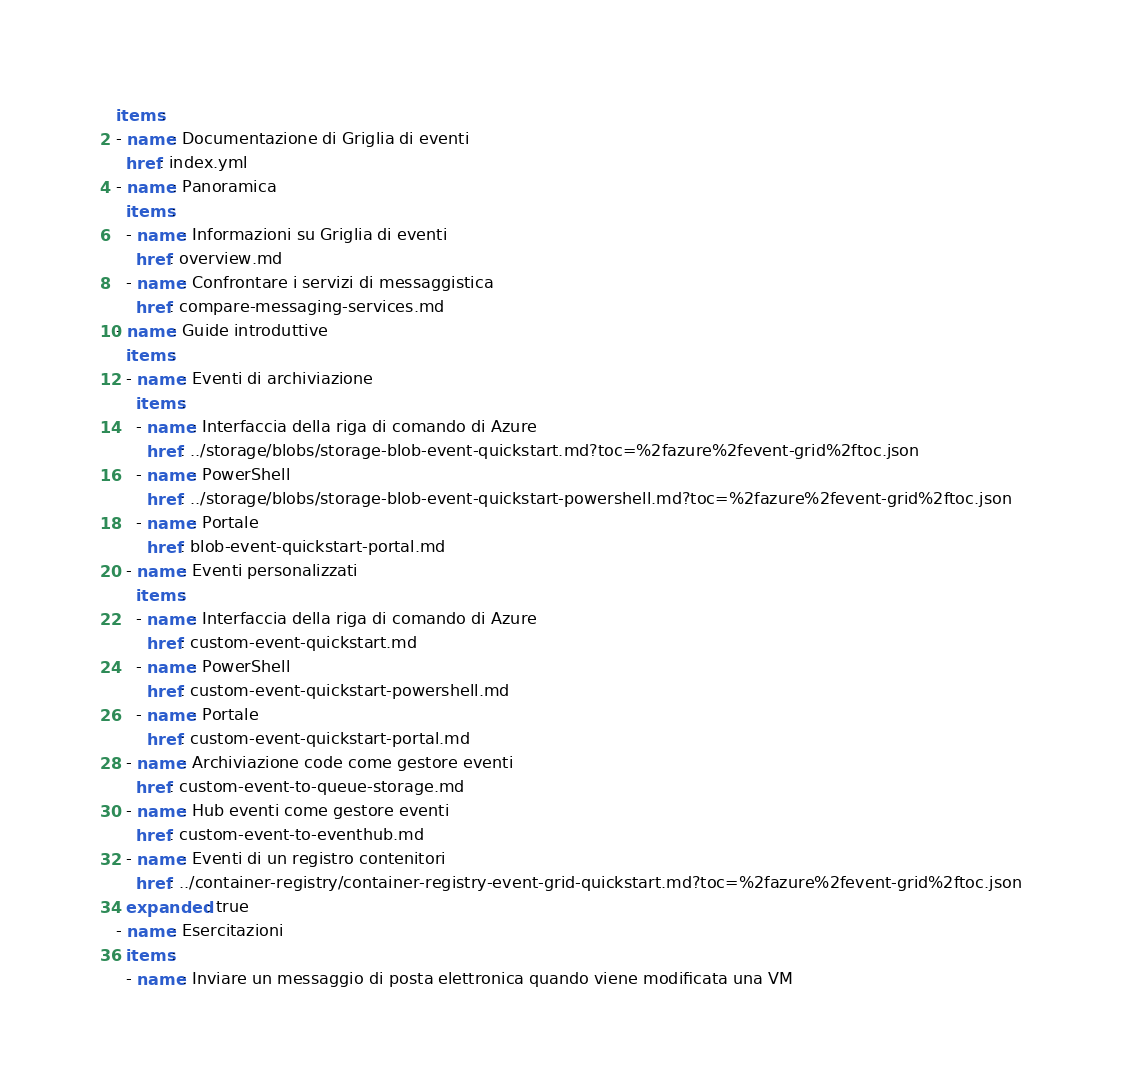<code> <loc_0><loc_0><loc_500><loc_500><_YAML_>items:
- name: Documentazione di Griglia di eventi
  href: index.yml
- name: Panoramica
  items:
  - name: Informazioni su Griglia di eventi
    href: overview.md
  - name: Confrontare i servizi di messaggistica
    href: compare-messaging-services.md
- name: Guide introduttive
  items:
  - name: Eventi di archiviazione
    items:
    - name: Interfaccia della riga di comando di Azure
      href: ../storage/blobs/storage-blob-event-quickstart.md?toc=%2fazure%2fevent-grid%2ftoc.json
    - name: PowerShell
      href: ../storage/blobs/storage-blob-event-quickstart-powershell.md?toc=%2fazure%2fevent-grid%2ftoc.json
    - name: Portale
      href: blob-event-quickstart-portal.md
  - name: Eventi personalizzati
    items:
    - name: Interfaccia della riga di comando di Azure
      href: custom-event-quickstart.md
    - name: PowerShell
      href: custom-event-quickstart-powershell.md
    - name: Portale
      href: custom-event-quickstart-portal.md
  - name: Archiviazione code come gestore eventi
    href: custom-event-to-queue-storage.md
  - name: Hub eventi come gestore eventi
    href: custom-event-to-eventhub.md
  - name: Eventi di un registro contenitori
    href: ../container-registry/container-registry-event-grid-quickstart.md?toc=%2fazure%2fevent-grid%2ftoc.json
  expanded: true
- name: Esercitazioni
  items:
  - name: Inviare un messaggio di posta elettronica quando viene modificata una VM</code> 